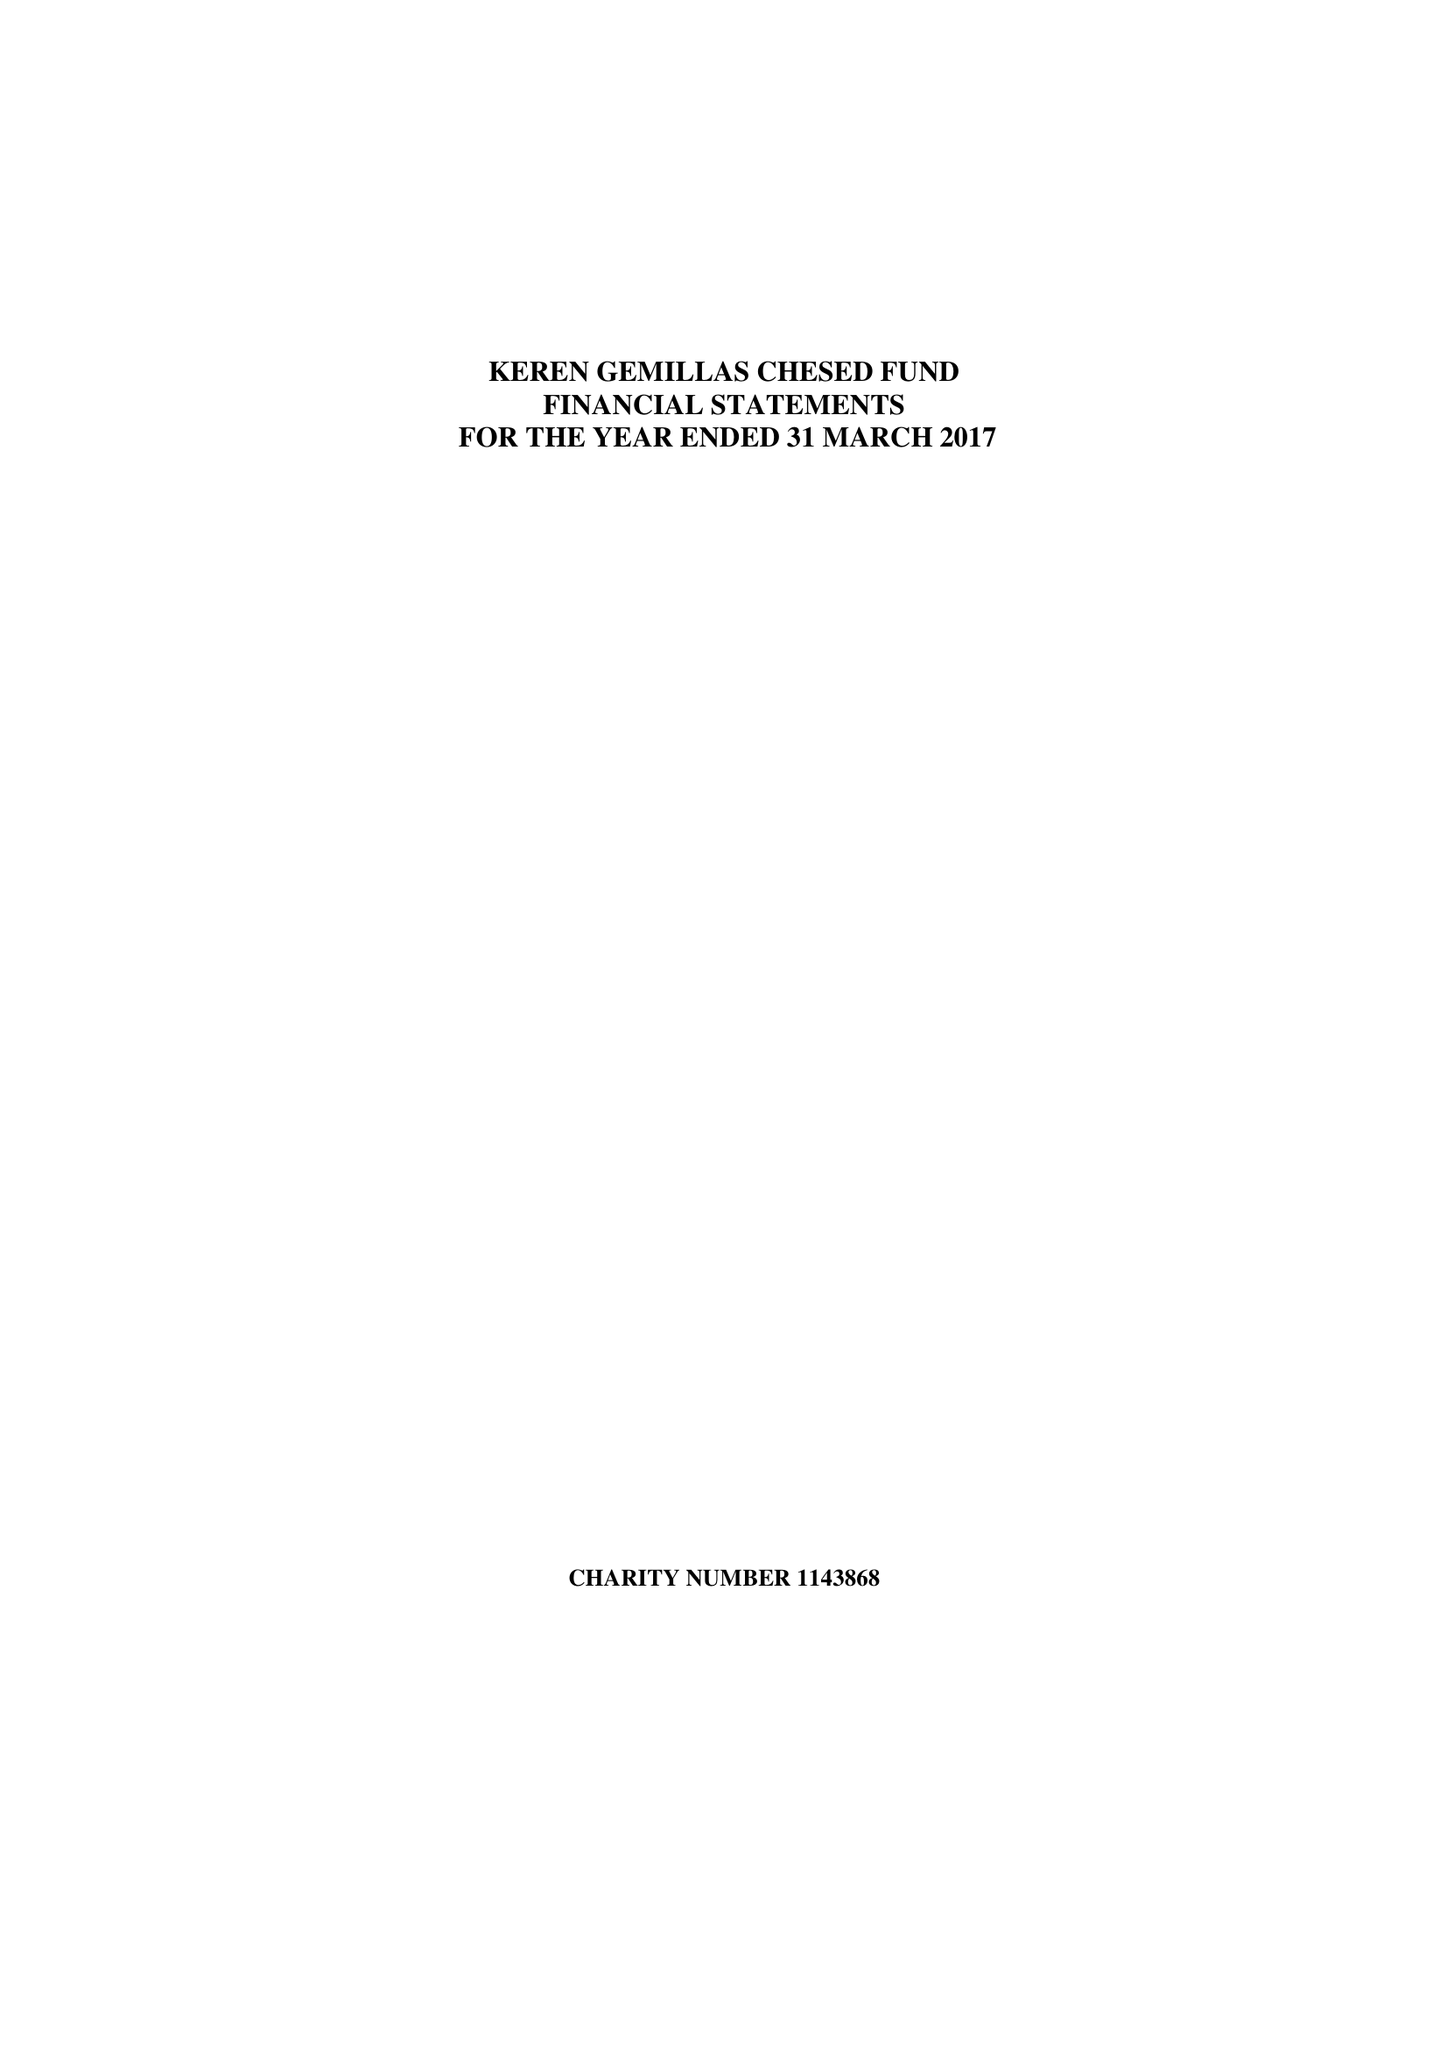What is the value for the report_date?
Answer the question using a single word or phrase. 2017-03-31 